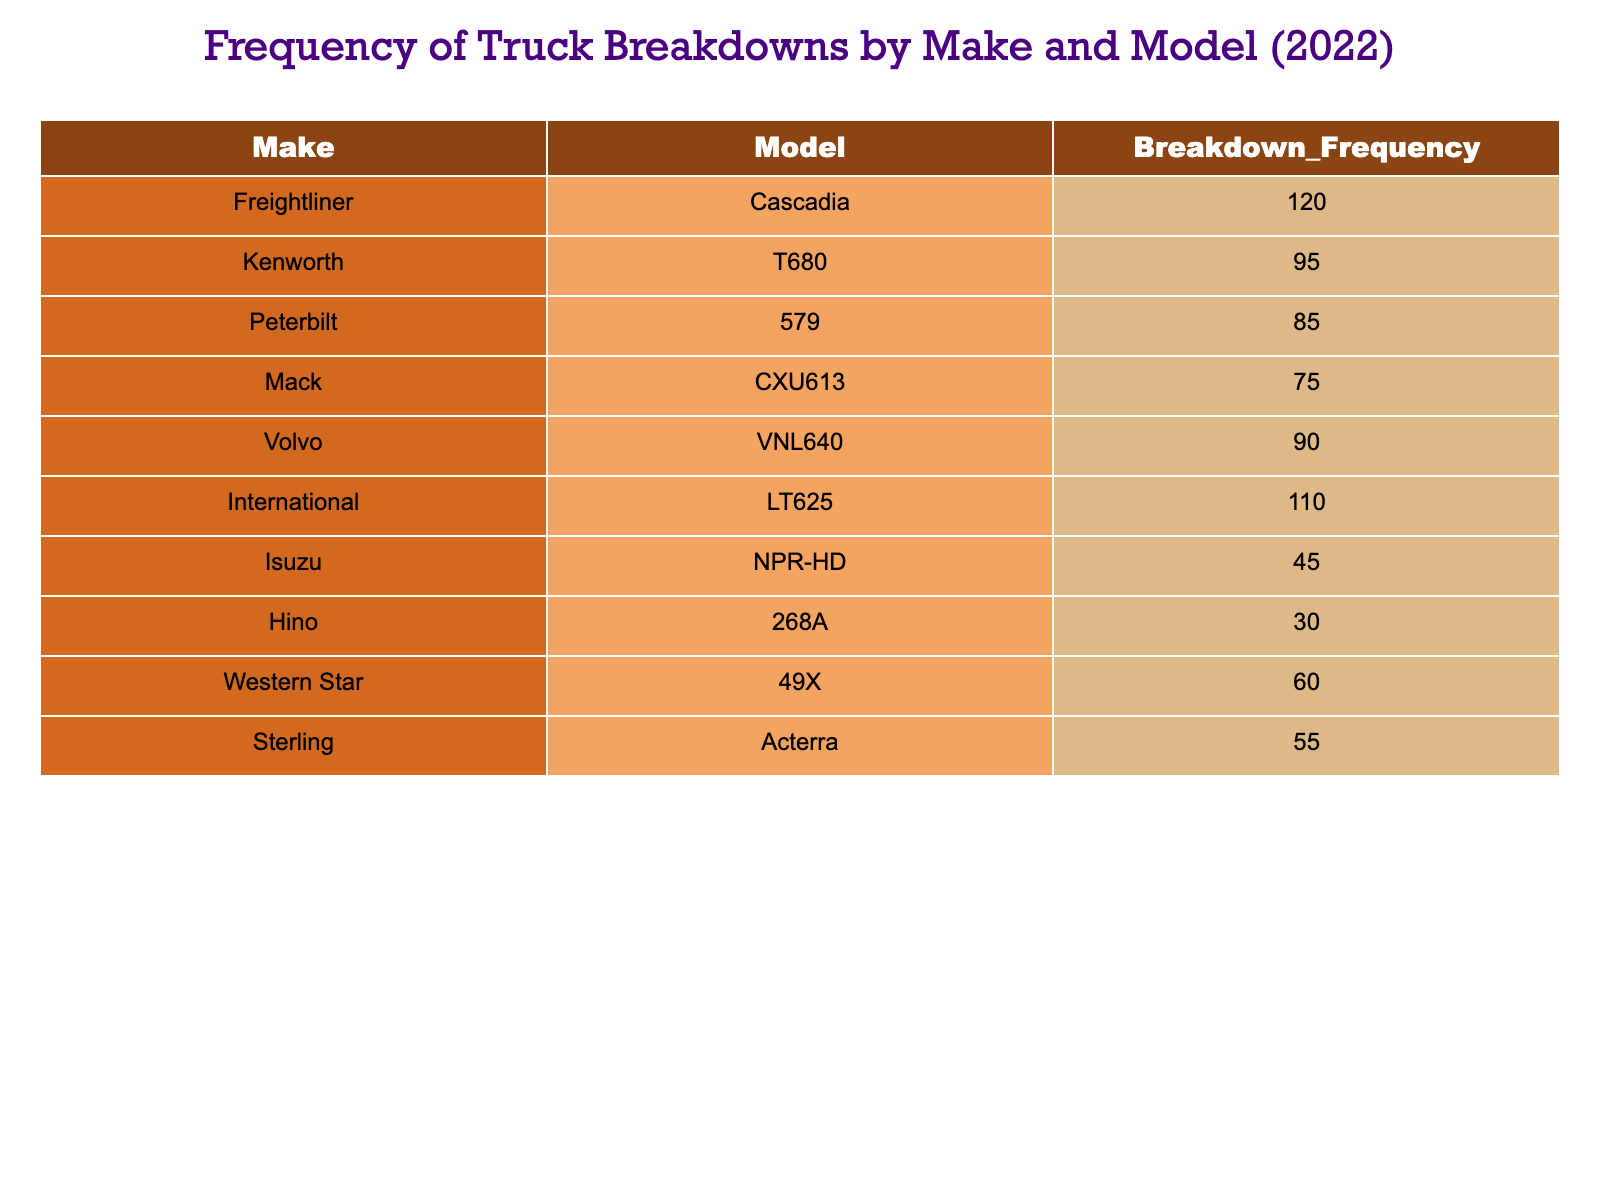What is the make and model with the highest breakdown frequency? The breakdown frequency values are presented in the table. Looking through them, the make and model with the highest frequency is Freightliner, Cascadia, with a frequency of 120.
Answer: Freightliner, Cascadia What is the breakdown frequency of the Peterbilt 579? The table explicitly lists the breakdown frequency of the Peterbilt 579, which is 85.
Answer: 85 Which truck make has the lowest breakdown frequency? By scanning through the table for the lowest frequency value, we find that the Isuzu NPR-HD has the lowest frequency at 45.
Answer: Isuzu, NPR-HD What is the average breakdown frequency for trucks listed in the table? To find the average, we first sum the breakdown frequencies: 120 + 95 + 85 + 75 + 90 + 110 + 45 + 30 + 60 + 55 = 765. Then, we divide by the number of makes and models (10): 765 / 10 = 76.5.
Answer: 76.5 Is the breakdown frequency of the Volvo VNL640 greater than 80? The breakdown frequency for Volvo VNL640 is listed as 90, which is indeed greater than 80.
Answer: Yes How many truck makes have a breakdown frequency less than 70? Reviewing the table, the trucks with frequencies below 70 are Hino with 30 and Isuzu with 45. Thus, there are 2 makes with frequencies less than 70.
Answer: 2 What is the difference in breakdown frequency between the International LT625 and the Kenworth T680? The breakdown frequency for International LT625 is 110, and for Kenworth T680 it is 95. The difference is calculated as 110 - 95 = 15.
Answer: 15 How many truck models have a breakdown frequency of 90 or above? From the table, the models with a frequency of 90 or above are Freightliner Cascadia (120), International LT625 (110), Volvo VNL640 (90), and Kenworth T680 (95). Counting these yields a total of 4.
Answer: 4 Is there a truck make that has the same breakdown frequency as the Western Star 49X? The Western Star 49X has a frequency of 60. Looking at the table, the Sterling Acterra also has the same frequency of 55. Hence, there is no truck make with a breakdown frequency equal to the Western Star 49X.
Answer: No 